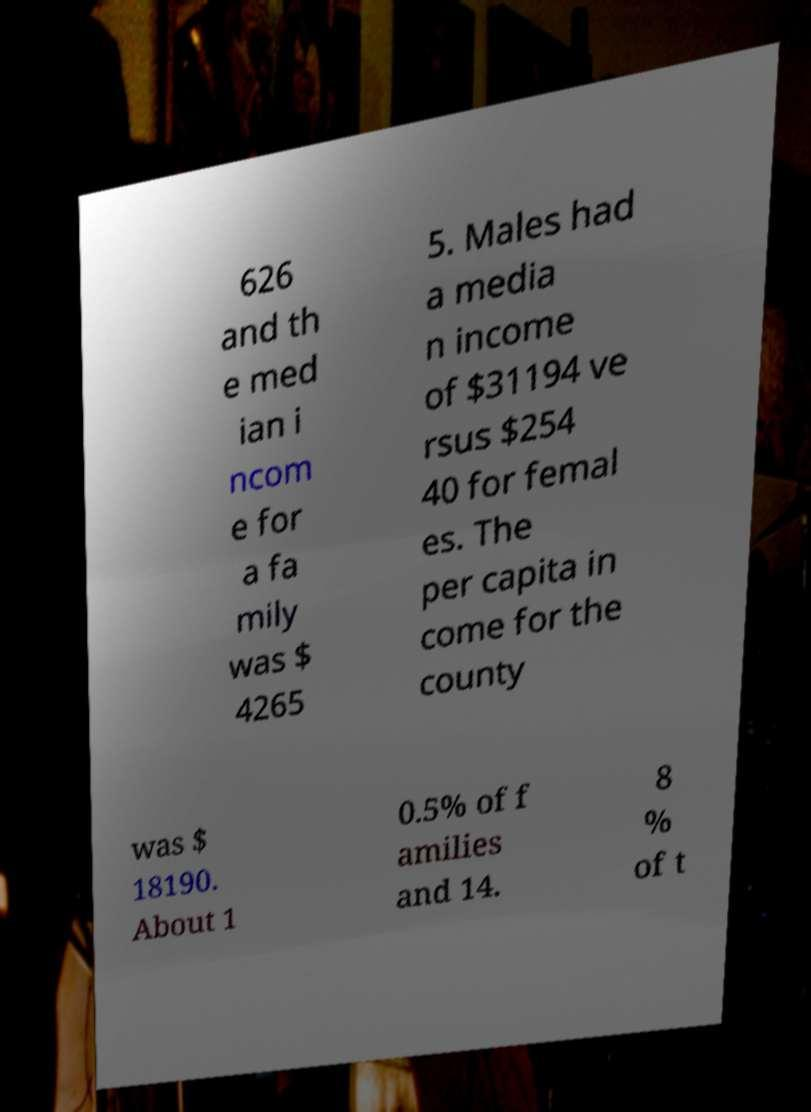Could you extract and type out the text from this image? 626 and th e med ian i ncom e for a fa mily was $ 4265 5. Males had a media n income of $31194 ve rsus $254 40 for femal es. The per capita in come for the county was $ 18190. About 1 0.5% of f amilies and 14. 8 % of t 